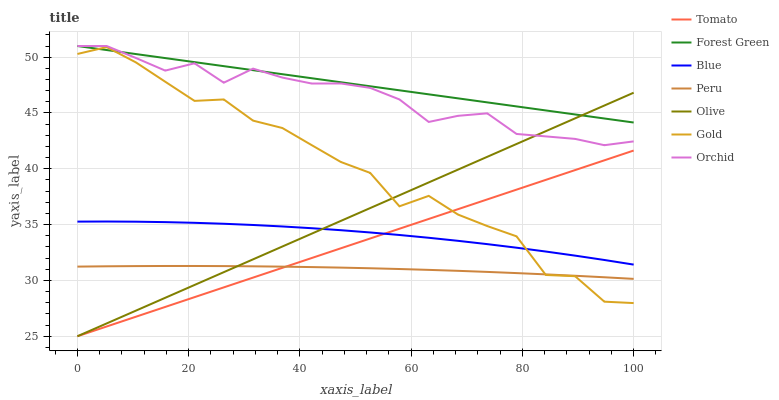Does Peru have the minimum area under the curve?
Answer yes or no. Yes. Does Forest Green have the maximum area under the curve?
Answer yes or no. Yes. Does Blue have the minimum area under the curve?
Answer yes or no. No. Does Blue have the maximum area under the curve?
Answer yes or no. No. Is Forest Green the smoothest?
Answer yes or no. Yes. Is Gold the roughest?
Answer yes or no. Yes. Is Blue the smoothest?
Answer yes or no. No. Is Blue the roughest?
Answer yes or no. No. Does Tomato have the lowest value?
Answer yes or no. Yes. Does Blue have the lowest value?
Answer yes or no. No. Does Orchid have the highest value?
Answer yes or no. Yes. Does Blue have the highest value?
Answer yes or no. No. Is Peru less than Orchid?
Answer yes or no. Yes. Is Blue greater than Peru?
Answer yes or no. Yes. Does Gold intersect Blue?
Answer yes or no. Yes. Is Gold less than Blue?
Answer yes or no. No. Is Gold greater than Blue?
Answer yes or no. No. Does Peru intersect Orchid?
Answer yes or no. No. 